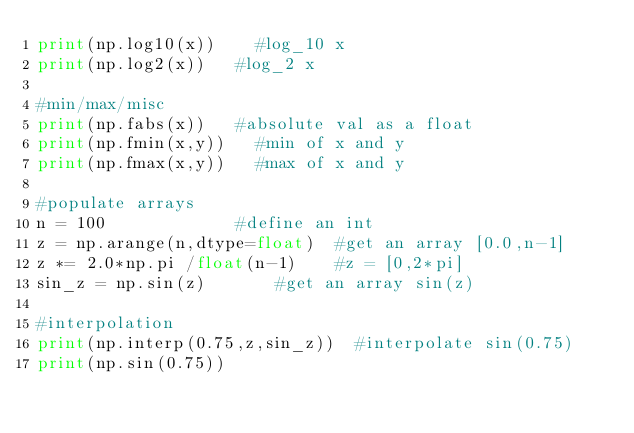<code> <loc_0><loc_0><loc_500><loc_500><_Python_>print(np.log10(x))		#log_10 x
print(np.log2(x))		#log_2 x

#min/max/misc
print(np.fabs(x))		#absolute val as a float
print(np.fmin(x,y))		#min of x and y
print(np.fmax(x,y))		#max of x and y

#populate arrays
n = 100							#define an int
z = np.arange(n,dtype=float)	#get an array [0.0,n-1]
z *= 2.0*np.pi /float(n-1)		#z = [0,2*pi]
sin_z = np.sin(z)				#get an array sin(z)

#interpolation
print(np.interp(0.75,z,sin_z))	#interpolate sin(0.75)
print(np.sin(0.75))
</code> 